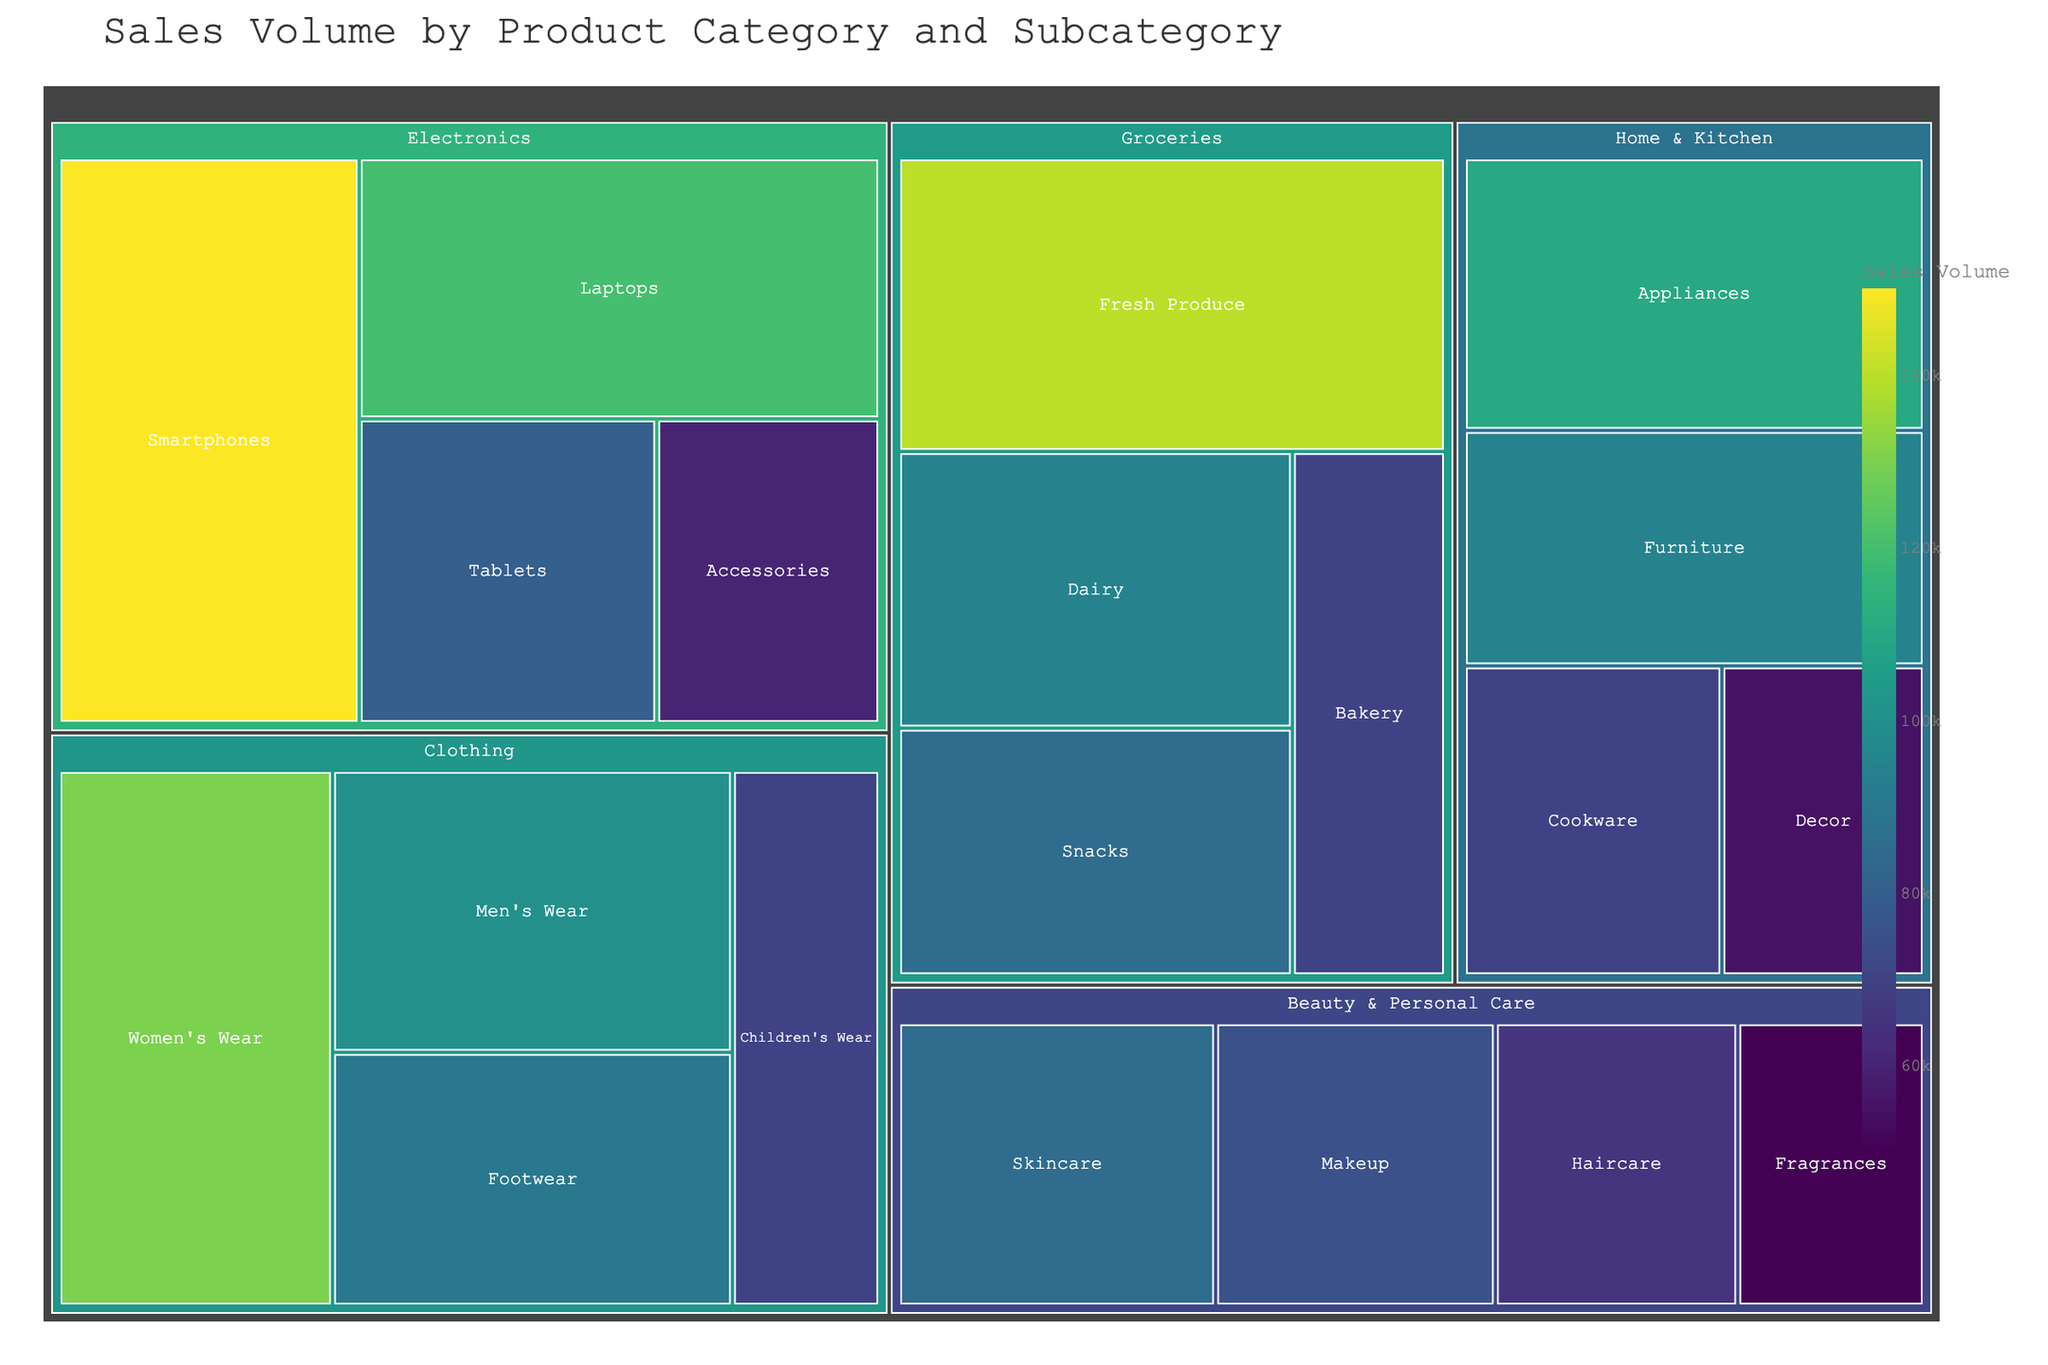What's the title of the treemap? The title is typically located at the top of the figure. The rendered figure has "Sales Volume by Product Category and Subcategory" as its title.
Answer: Sales Volume by Product Category and Subcategory Which subcategory in the Electronics category has the highest sales volume? In the Electronics category, we compare the sales volumes of the subcategories. Smartphones have a sales volume of 150,000, which is the highest.
Answer: Smartphones How much higher is the sales volume of Women's Wear compared to Men's Wear? Compare the sales volumes of Women's Wear (130,000) and Men's Wear (100,000). Subtract the sales volume of Men's Wear from Women's Wear: 130,000 - 100,000 = 30,000.
Answer: 30,000 Which category has the smallest sales volume subcategory, and what is it? Find the subcategory with the smallest sales volume across all categories. "Fragrances" in Beauty & Personal Care has the smallest sales volume, 50,000.
Answer: Beauty & Personal Care, Fragrances What are the top three subcategories with the highest sales volumes? Identify the three subcategories with the highest sales volumes: Smartphones (150,000), Fresh Produce (140,000), and Women's Wear (130,000).
Answer: Smartphones, Fresh Produce, Women's Wear What is the cumulative sales volume for the Home & Kitchen category? Add the sales volumes of all subcategories within Home & Kitchen: 110,000 (Appliances) + 70,000 (Cookware) + 95,000 (Furniture) + 55,000 (Decor) = 330,000.
Answer: 330,000 Which category has the most number of subcategories, and how many does it have? Check the number of subcategories for each category. Electronics, Clothing, Home & Kitchen, Beauty & Personal Care, and Groceries each have 4 subcategories.
Answer: Electronics, Clothing, Home & Kitchen, Beauty & Personal Care, Groceries; 4 Which category has the highest total sales volume? Sum the sales volumes of subcategories for each category: 
Electronics: 150,000 + 120,000 + 80,000 + 60,000 = 410,000 
Clothing: 100,000 + 130,000 + 70,000 + 90,000 = 390,000 
Home & Kitchen: 110,000 + 70,000 + 95,000 + 55,000 = 330,000 
Beauty & Personal Care: 85,000 + 65,000 + 75,000 + 50,000 = 275,000 
Groceries: 140,000 + 95,000 + 70,000 + 85,000 = 390,000 
Electronics has the highest total sales volume of 410,000.
Answer: Electronics How does the sales volume of the largest subcategory in Beauty & Personal Care compare to the smallest subcategory in Groceries? Compare the sales volumes:
Skincare (largest in Beauty & Personal Care): 85,000
Bakery (smallest in Groceries): 70,000
85,000 is greater than 70,000.
Answer: 85,000 > 70,000 